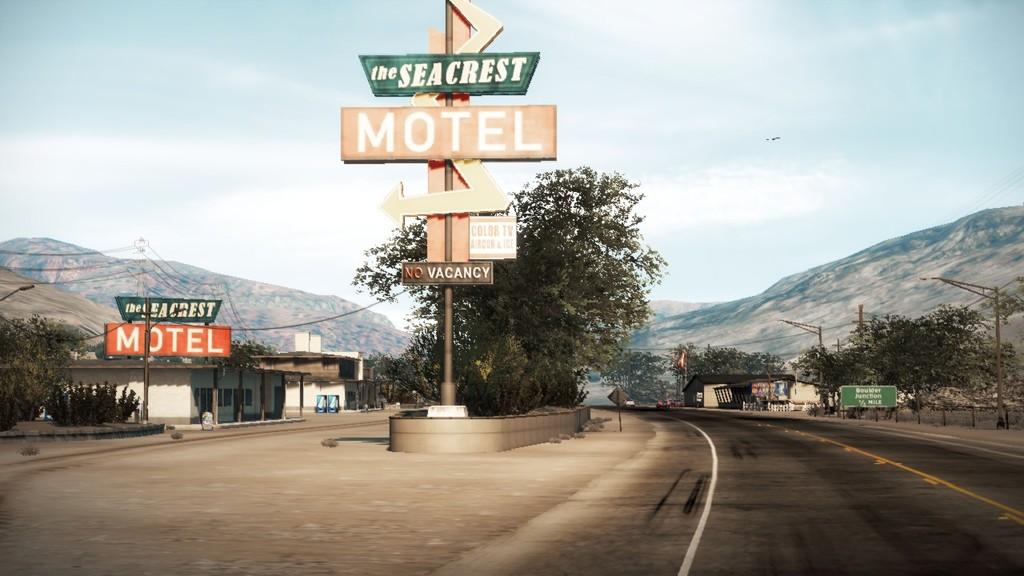What's the name of the motel?
Offer a very short reply. The seacrest. What kind of establishment is this?
Your answer should be compact. Motel. 